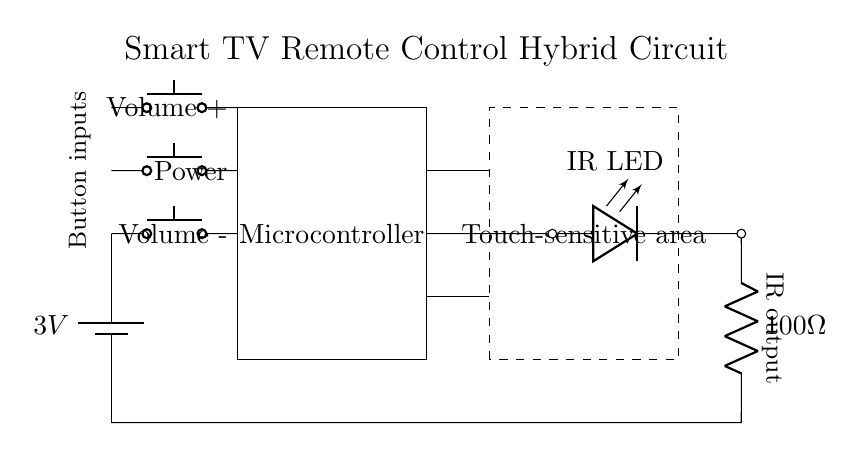What is the voltage of the power supply? The diagram indicates a battery labeled with a voltage of 3 volts, which specifies the potential difference provided by the power supply.
Answer: 3 volts What type of component is used for the IR output? The diagram shows an LED labeled as "IR LED," which is a specific type of light-emitting diode designed to emit infrared light, commonly used for remote controls.
Answer: IR LED How many buttons are present in the circuit? The circuit diagram displays three push buttons labeled for different functions: Power, Volume +, and Volume -, indicating there are three buttons in total.
Answer: 3 What is the resistance value connected to the IR LED? In the diagram, there is a resistor labeled with a value of 100 ohms connected in series with the IR LED, which functions to limit the current flowing through the LED.
Answer: 100 ohms What is the orientation of the microcontroller in the circuit? The microcontroller is depicted as a rectangular block in the diagram, positioned vertically between two components, suggesting a standard sitting position in electronic circuit layouts.
Answer: Vertical Which section is designed for touch sensitivity? The circuit features a dashed rectangle labeled "Touch-sensitive area," indicating this specific section is intended for touch-based interaction.
Answer: Touch-sensitive area How is the connection made from the buttons to the microcontroller? The diagram illustrates wires leading directly from each push button towards the microcontroller, indicating a straightforward connection allowing button presses to signal the microcontroller.
Answer: Direct connection 